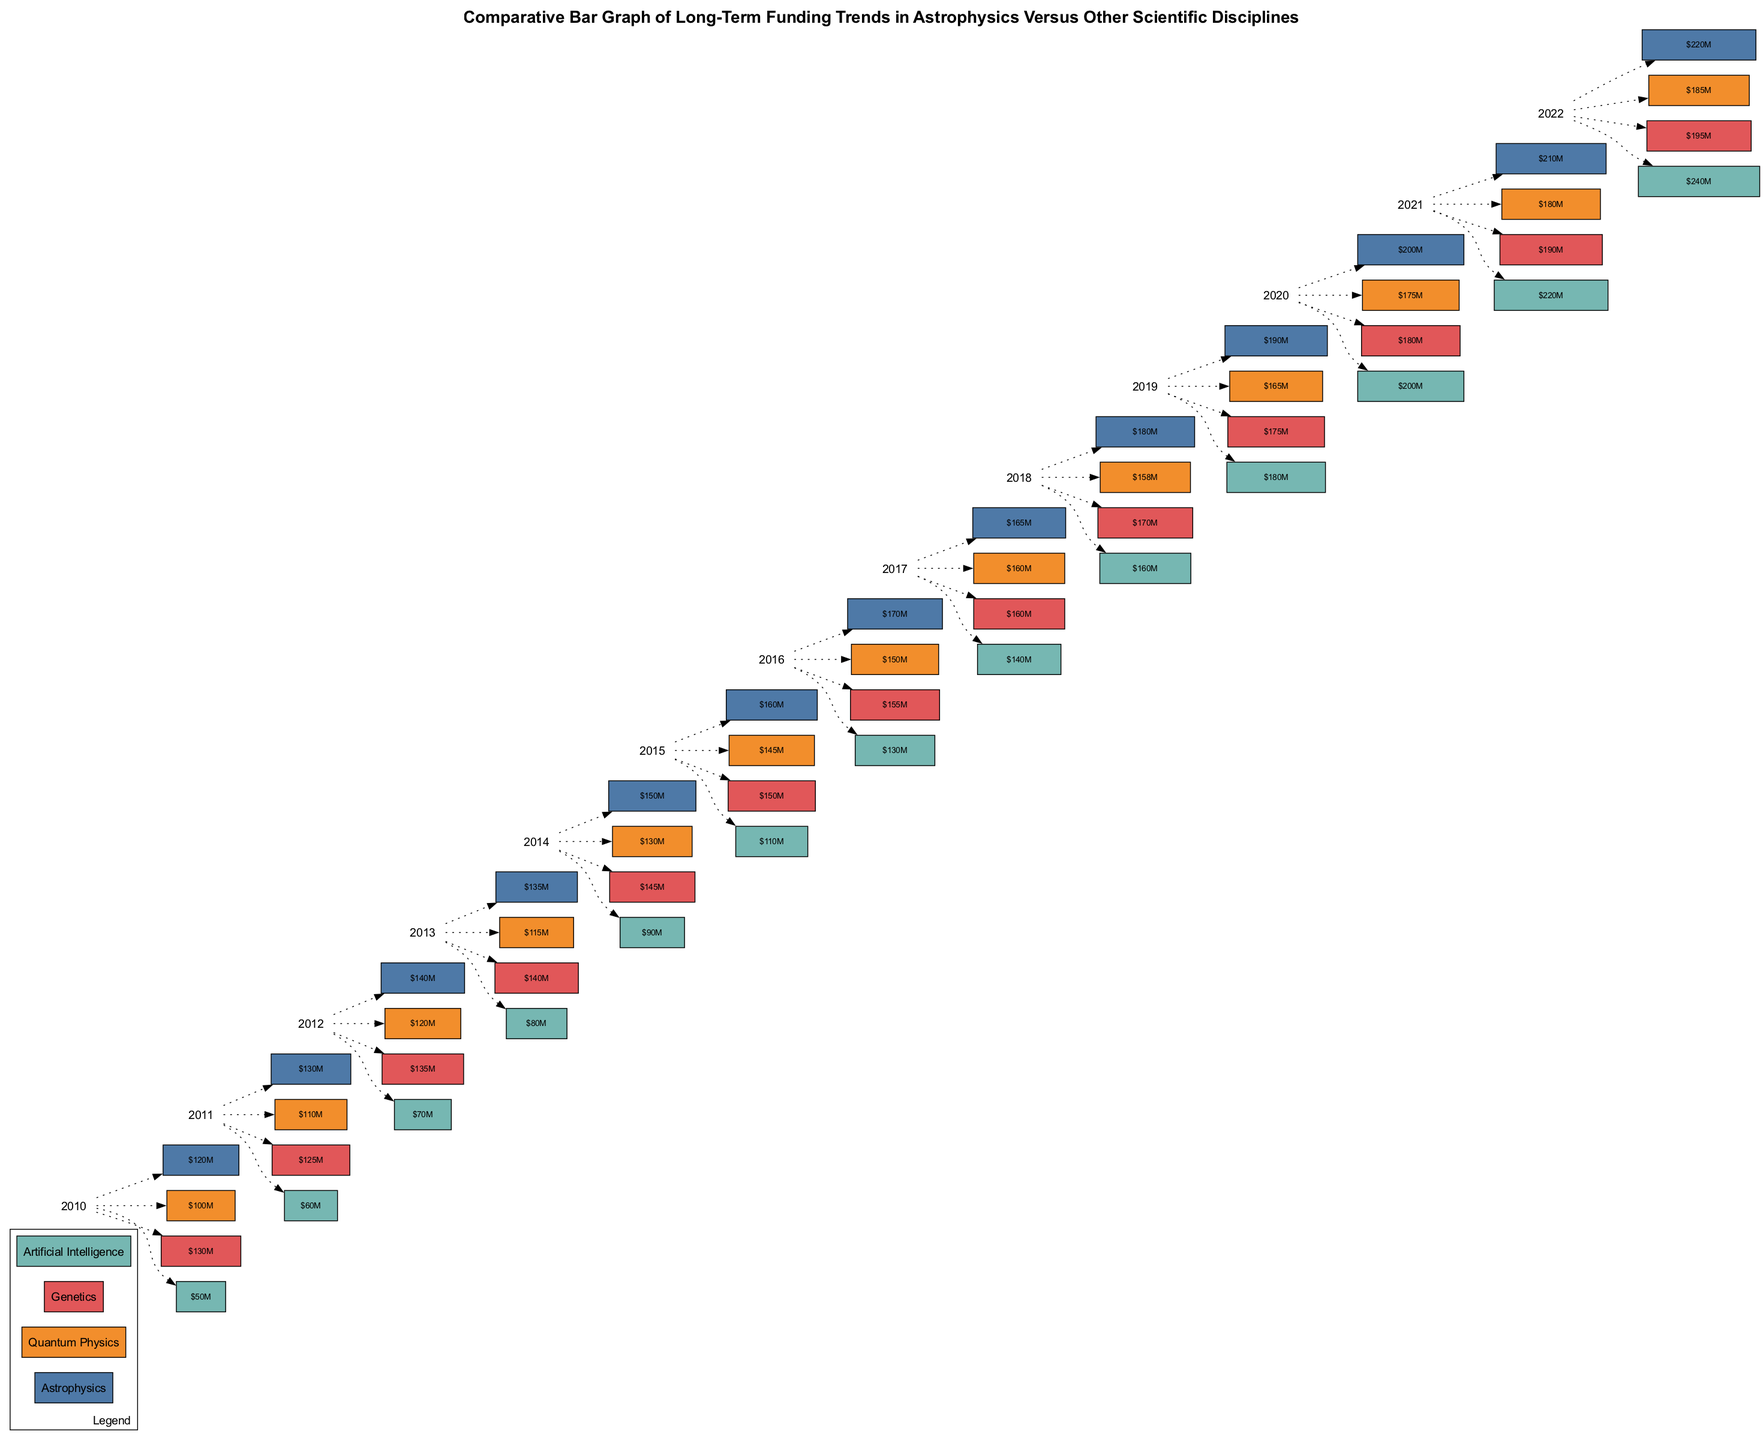What was the funding amount for Astrophysics in 2022? By locating the year 2022 on the x-axis and observing the corresponding box for Astrophysics, the funding amount can be read directly. The amount shown is 220 million USD.
Answer: 220 million USD Which discipline had the highest amount of funding in 2019? To find the highest funding for 2019, we check the amounts listed for all disciplines in that year. Astrophysics had 190 million USD, Quantum Physics had 165 million USD, Genetics had 175 million USD, and Artificial Intelligence had 180 million USD. Comparing these, Astrophysics had the highest at 190 million USD.
Answer: Astrophysics How much did Artificial Intelligence receive in 2015? Looking at the bar corresponding to the year 2015 on the x-axis, we identify the amount allocated to Artificial Intelligence. The box shows 110 million USD for that year.
Answer: 110 million USD Which disciplines show a continuous increase in funding from 2010 to 2022? To answer this, we need to observe the funding trends for each discipline from 2010 to 2022 on the graph. Astrophysics shows an increase each year from 120 million USD in 2010 to 220 million USD in 2022; Genetics remains fairly stable with minor fluctuations but ends higher at 195 million USD; and Artificial Intelligence consistently rises from 50 million USD to 240 million USD, while Quantum Physics shows some fluctuations. Therefore, both Astrophysics and Artificial Intelligence exhibit a continuous increase.
Answer: Astrophysics, Artificial Intelligence What is the funding amount for Genetics in 2013? We identify the year 2013 on the x-axis and look at the corresponding amount on the Genetics box, which indicates 140 million USD.
Answer: 140 million USD How many disciplines had a higher funding amount than Quantum Physics in 2016? First, we locate Quantum Physics funding for 2016 on the bar graph, which is 150 million USD. Then, we compare the funding amounts for all disciplines in 2016: Astrophysics (170 million USD), Quantum Physics (150 million USD), Genetics (155 million USD), and Artificial Intelligence (130 million USD). Only Astrophysics and Genetics had higher funding amounts, thus there are two disciplines.
Answer: 2 In which year did Astrophysics funding increase by the largest dollar amount from the previous year? By examining the annual changes for Astrophysics, we calculate the differences: 130-120=10 (2011), 140-130=10 (2012), 135-140=-5 (2013), 150-135=15 (2014), 160-150=10 (2015), 170-160=10 (2016), 165-170=-5 (2017), 180-165=15 (2018), 190-180=10 (2019), 200-190=10 (2020), 210-200=10 (2021), and 220-210=10 (2022). The largest increase was 15 million USD, occurring in the years 2014 and 2018.
Answer: 2014, 2018 Which discipline showed the lowest funding in 2010? By reviewing the funding amounts in 2010: Astrophysics (120 million USD), Quantum Physics (100 million USD), Genetics (130 million USD), and Artificial Intelligence (50 million USD), we can see that Artificial Intelligence had the lowest funding.
Answer: Artificial Intelligence 